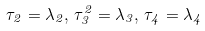<formula> <loc_0><loc_0><loc_500><loc_500>\tau _ { 2 } = \lambda _ { 2 } , \, \tau _ { 3 } ^ { 2 } = \lambda _ { 3 } , \, \tau _ { 4 } = \lambda _ { 4 }</formula> 